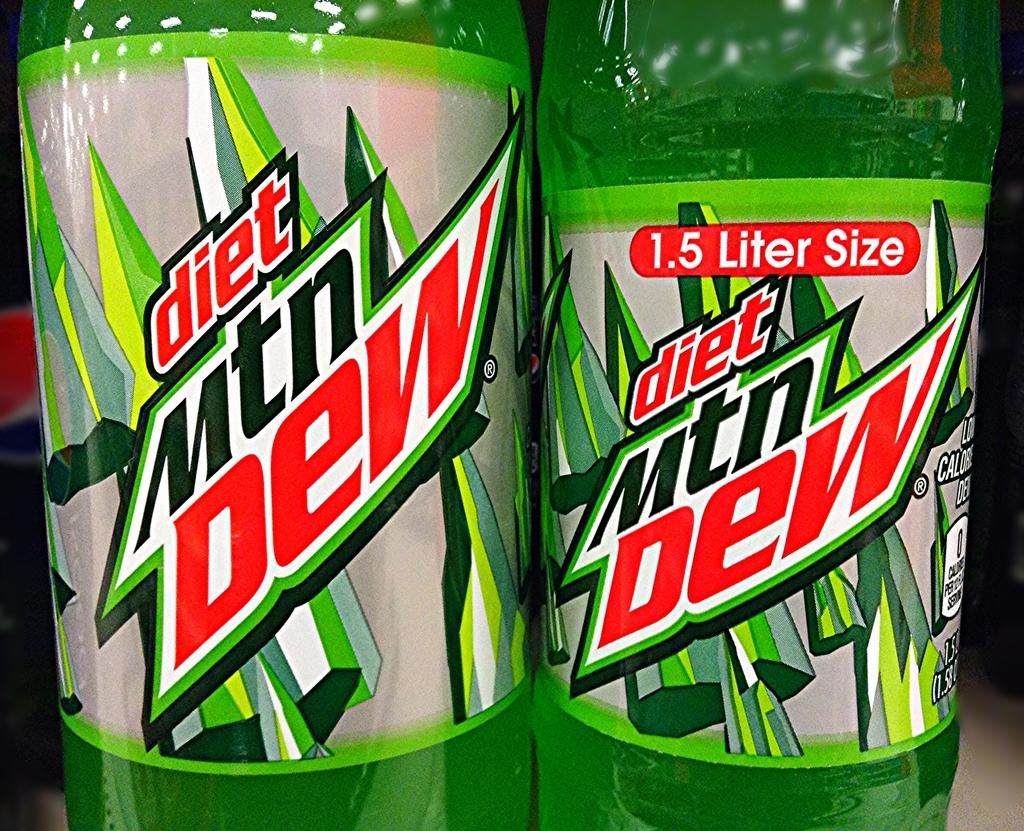What is the size of this drink?
Offer a terse response. 1.5 liter. What type of soda is in these bottles?
Your answer should be compact. Diet mountain dew. 